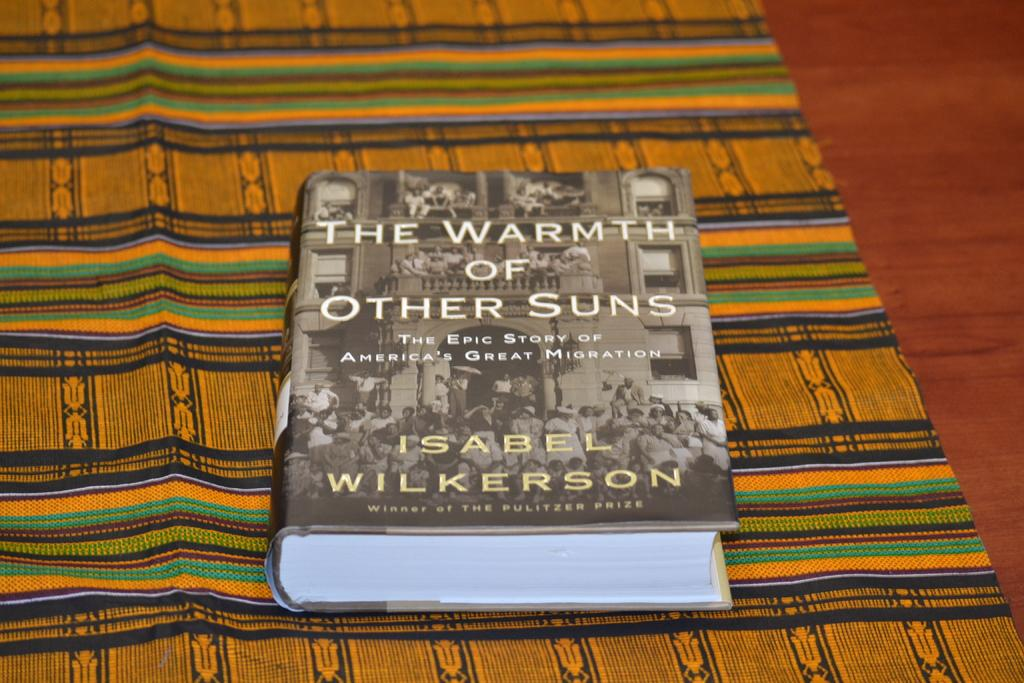What is the main object in the image? There is a book in the image. What is the book placed on? The book is on a cloth. Where is the cloth located? The cloth is on a platform. What types of images are present in the book? The book contains pictures of people and buildings. Is there any text in the book? Yes, there is text written on the book. What is the book teaching about in the image? The image does not provide information about what the book is teaching. What is the person's desire in the image? There is no person present in the image, so it is impossible to determine their desires. 